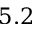<formula> <loc_0><loc_0><loc_500><loc_500>5 . 2</formula> 